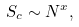<formula> <loc_0><loc_0><loc_500><loc_500>S _ { c } \sim N ^ { x } ,</formula> 